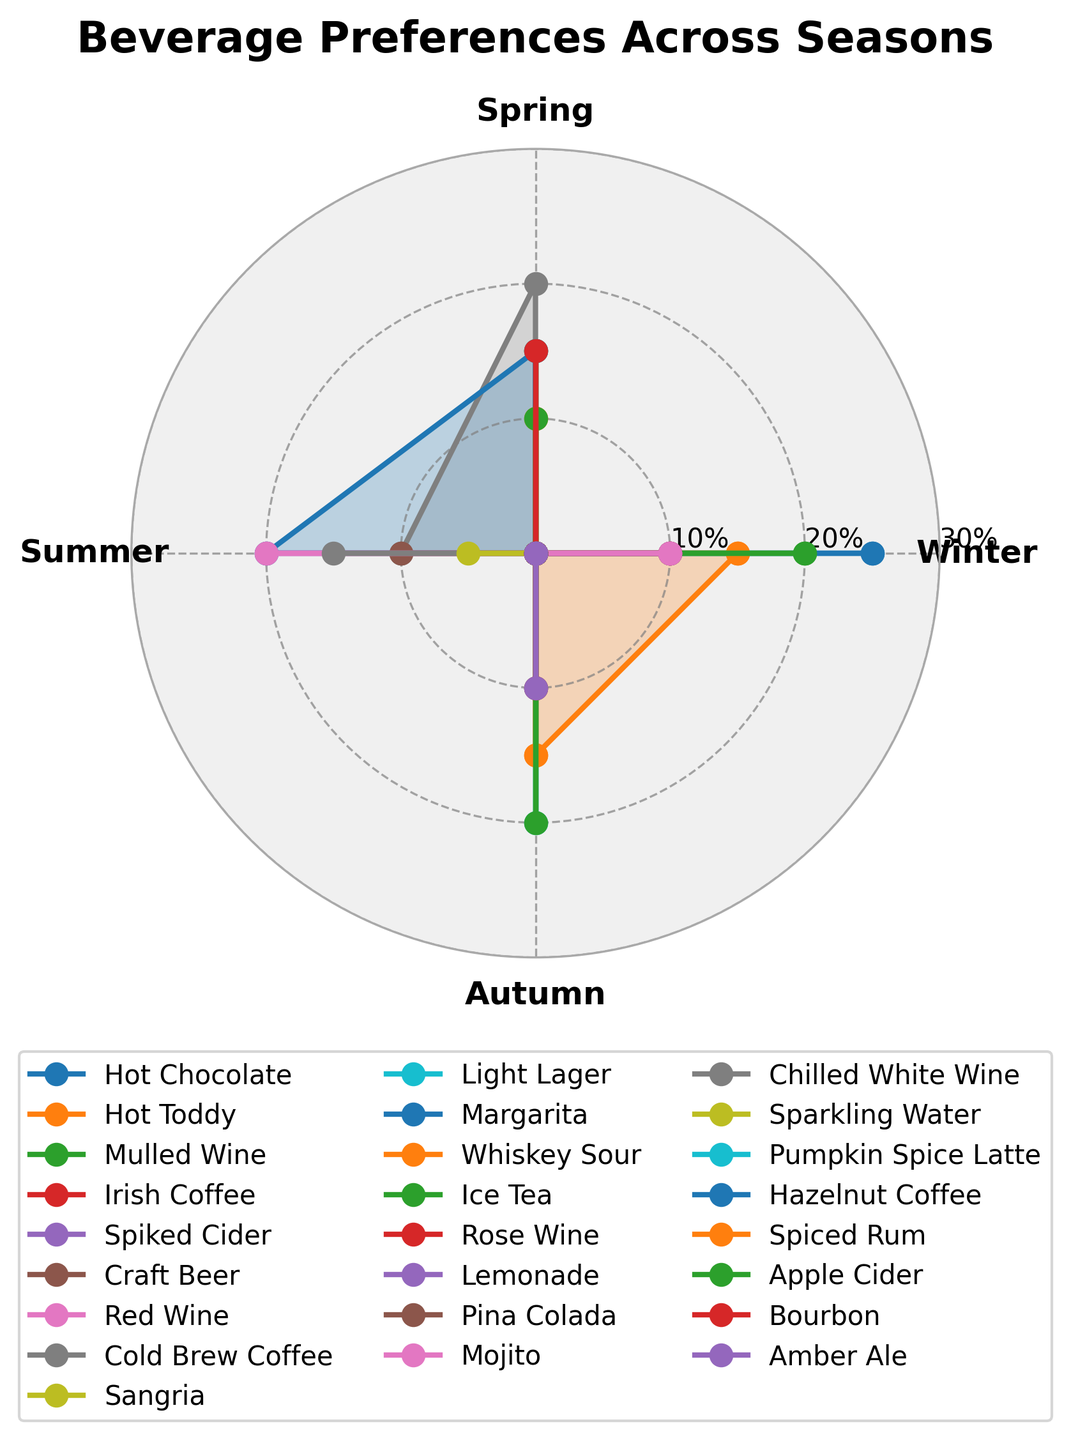What is the title of the polar chart? The title is usually placed at the top of the chart. Here, it indicates the main subject of the visual representation.
Answer: Beverage Preferences Across Seasons Which season shows the highest preference for Hot Chocolate? By comparing the lines corresponding to Hot Chocolate in each season, the peak value is found in Winter.
Answer: Winter How many beverage types are plotted in the chart? Each unique line style and color represents a different beverage type. Count the legend entries to determine the number of beverage types.
Answer: 23 Which beverage is equally preferred in both Winter and Autumn? Look for a beverage line that intersects the same radius value at points labeled Winter and Autumn. Hot Toddy has the same percentage (15%) in both seasons.
Answer: Hot Toddy What is the sum of preferences for Margarita across all seasons? Add the percentage values for Margarita(0% Winter, 15% Spring, 20% Summer, 0% Autumn). 0+15+20+0 = 35.
Answer: 35% Between Spring and Summer, in which season is Cold Brew Coffee more preferred? Compare the radius lengths of Cold Brew Coffee for Spring and Summer. Spring has 20% and Summer has 10%.
Answer: Spring Which season has the least variety of beverages with significant preferences (above 10%)? Count the number of beverages with percentages above 10% in each season by examining the intersections of the lines with high radius values.
Answer: Autumn (5 beverages) Is there any beverage that has the same preference value in three different seasons? Look for a line that intersects the same radius value at three seasonal points. With careful inspection, no single beverage has the same percentage across three seasons.
Answer: No Which season shows the maximum preference for Pumpkin Spice Latte? Look carefully at the percentage value intersection of Pumpkin Spice Latte, finding the peak value in Autumn with 20%.
Answer: Autumn 